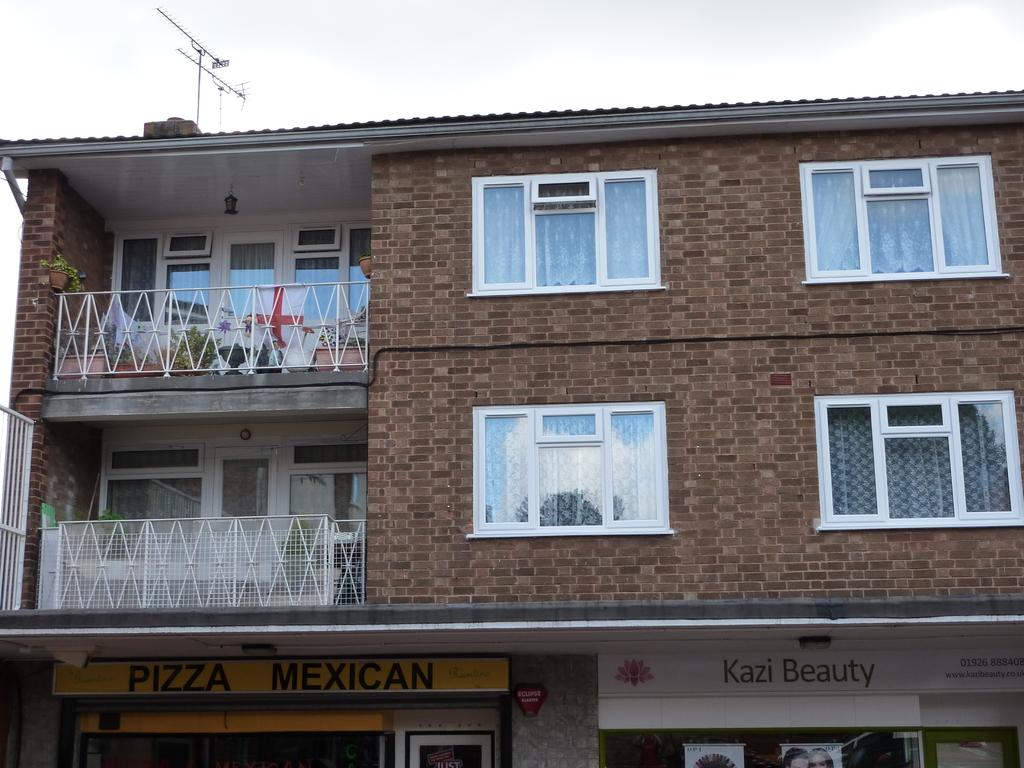What type of structure is present in the image? There is a building in the image. What can be found beneath the building? There are two stores under the building. What type of collar is being offered by the stores in the image? There is no collar mentioned or visible in the image; the stores are not specified in terms of their products or services. 